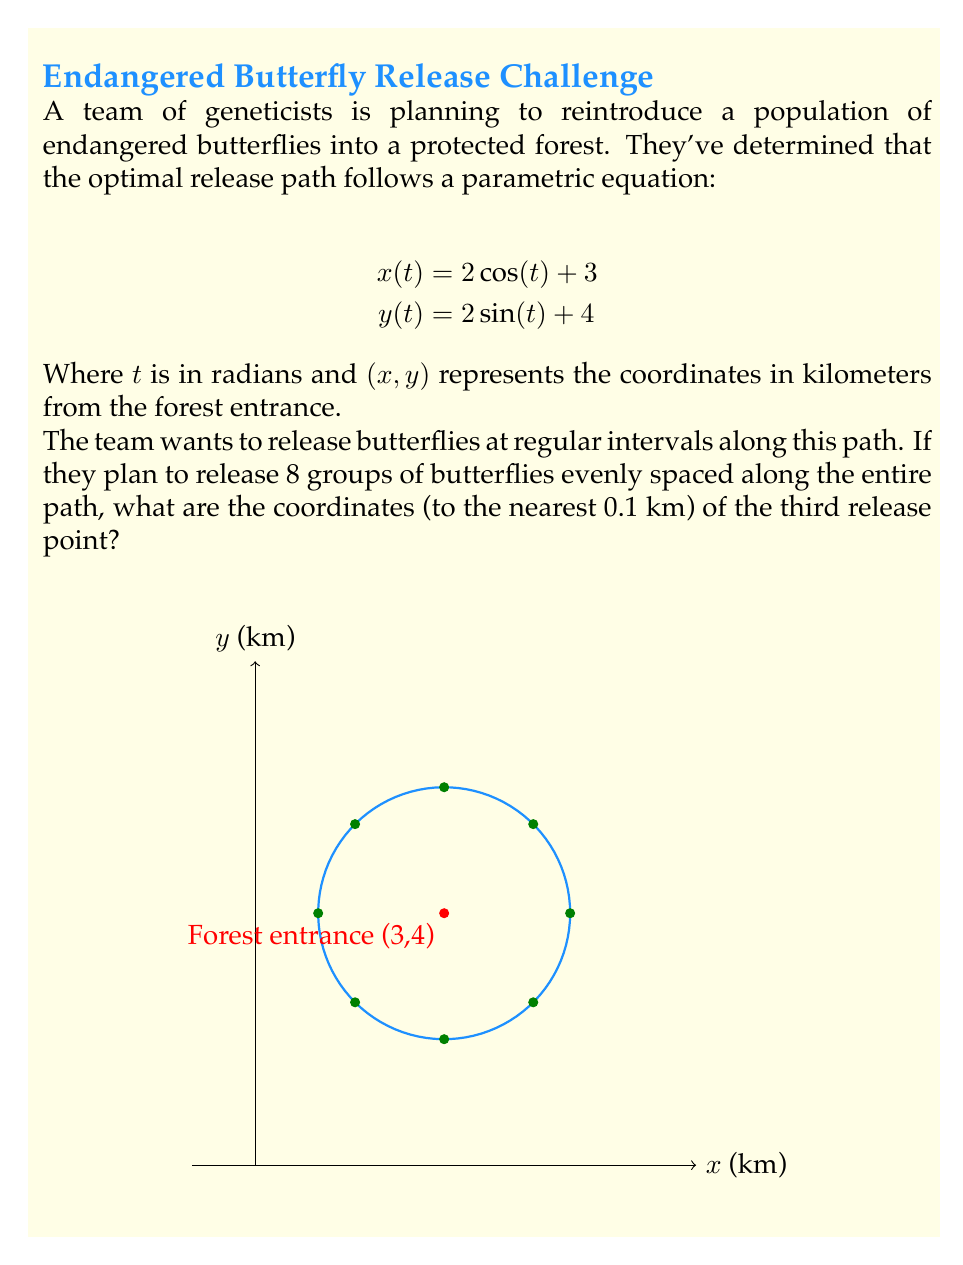What is the answer to this math problem? Let's approach this step-by-step:

1) The parametric equations describe a circle with radius 2, centered at (3,4).

2) The path completes one full revolution as $t$ goes from 0 to $2\pi$.

3) For 8 evenly spaced points, we need to divide the path into 8 equal parts. This means we'll use $t = 0, \frac{2\pi}{8}, \frac{4\pi}{8}, \frac{6\pi}{8}, ..., \frac{14\pi}{8}$.

4) The third release point corresponds to $t = \frac{4\pi}{8} = \frac{\pi}{2}$.

5) Let's calculate the coordinates for this point:

   $x(\frac{\pi}{2}) = 2\cos(\frac{\pi}{2}) + 3 = 2(0) + 3 = 3$

   $y(\frac{\pi}{2}) = 2\sin(\frac{\pi}{2}) + 4 = 2(1) + 4 = 6$

6) Therefore, the coordinates of the third release point are (3, 6).

7) The question asks for the answer to the nearest 0.1 km, but our result is already in whole numbers, so no further rounding is necessary.
Answer: (3.0, 6.0) 